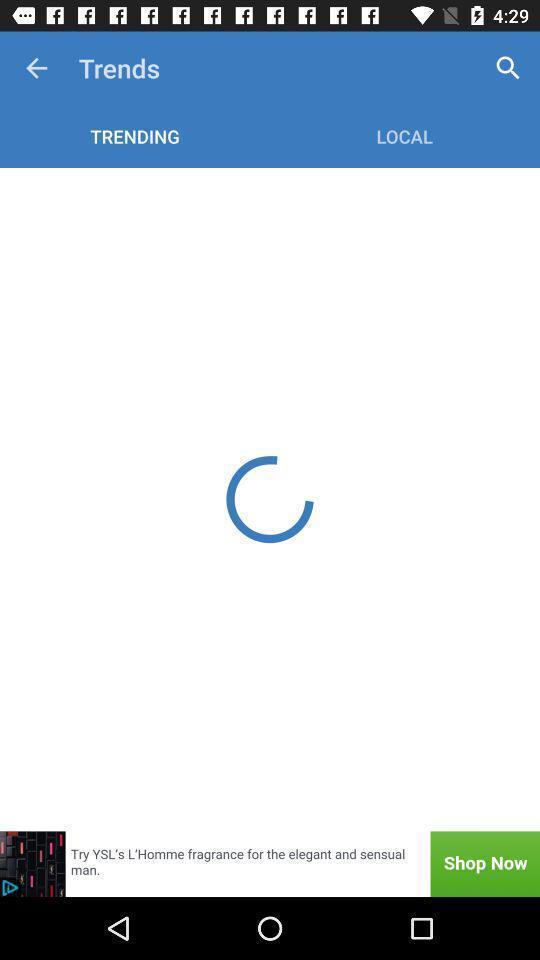Tell me about the visual elements in this screen capture. Page displaying loading status with different options. 